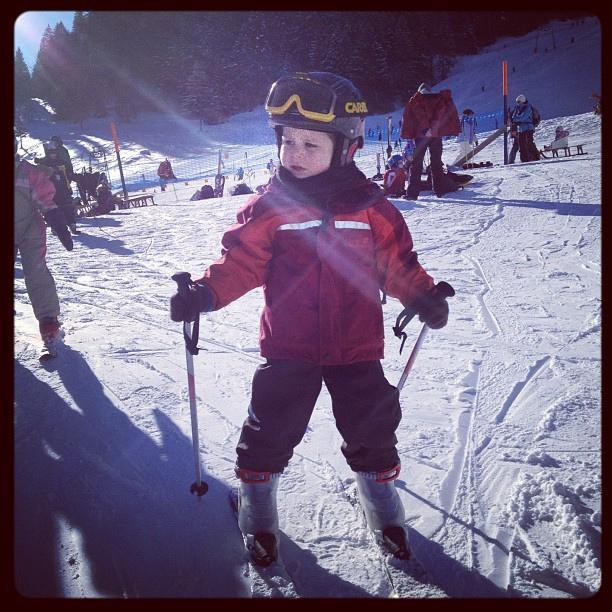How many people can you see?
Give a very brief answer. 3. 